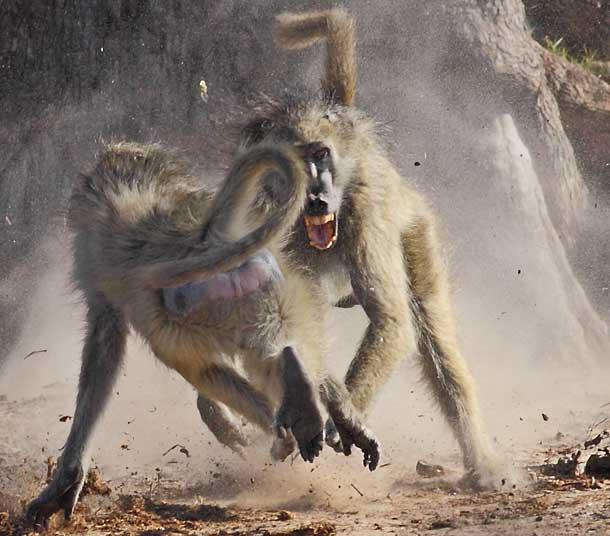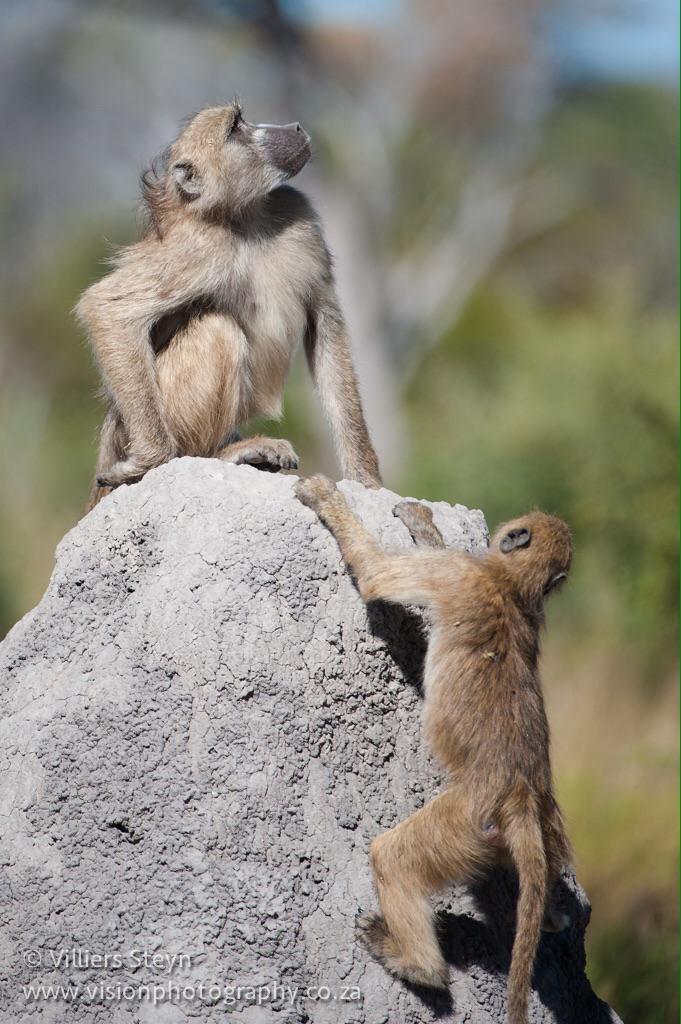The first image is the image on the left, the second image is the image on the right. For the images displayed, is the sentence "The right image contains no more than two monkeys." factually correct? Answer yes or no. Yes. The first image is the image on the left, the second image is the image on the right. Assess this claim about the two images: "Both images show multiple monkeys in pools of water.". Correct or not? Answer yes or no. No. 